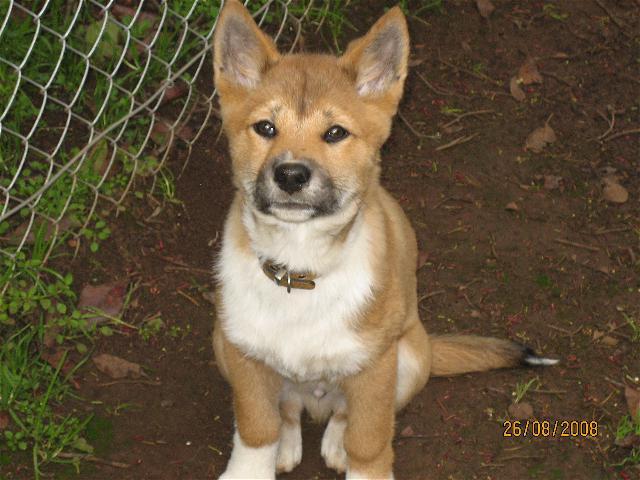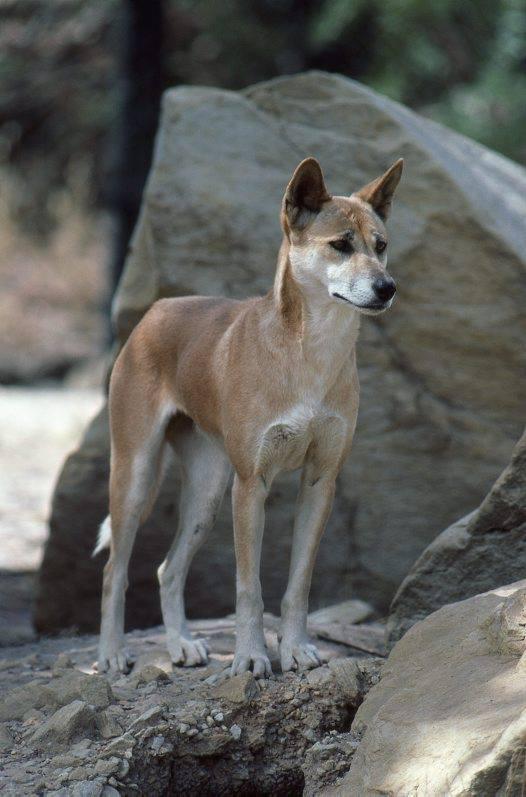The first image is the image on the left, the second image is the image on the right. For the images shown, is this caption "An image contains only one dog, which is standing on a rock gazing rightward." true? Answer yes or no. Yes. The first image is the image on the left, the second image is the image on the right. Evaluate the accuracy of this statement regarding the images: "There are no more than 3 dogs in total.". Is it true? Answer yes or no. Yes. 